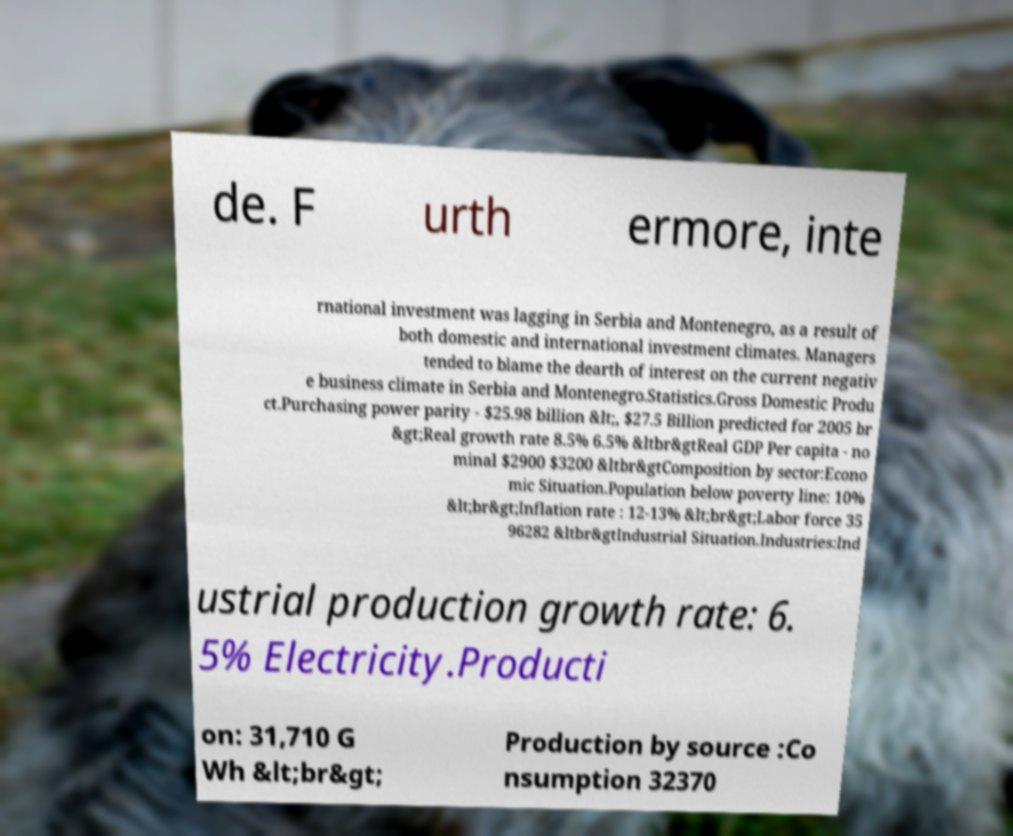Could you extract and type out the text from this image? de. F urth ermore, inte rnational investment was lagging in Serbia and Montenegro, as a result of both domestic and international investment climates. Managers tended to blame the dearth of interest on the current negativ e business climate in Serbia and Montenegro.Statistics.Gross Domestic Produ ct.Purchasing power parity - $25.98 billion &lt;, $27.5 Billion predicted for 2005 br &gt;Real growth rate 8.5% 6.5% &ltbr&gtReal GDP Per capita - no minal $2900 $3200 &ltbr&gtComposition by sector:Econo mic Situation.Population below poverty line: 10% &lt;br&gt;Inflation rate : 12-13% &lt;br&gt;Labor force 35 96282 &ltbr&gtIndustrial Situation.Industries:Ind ustrial production growth rate: 6. 5% Electricity.Producti on: 31,710 G Wh &lt;br&gt; Production by source :Co nsumption 32370 